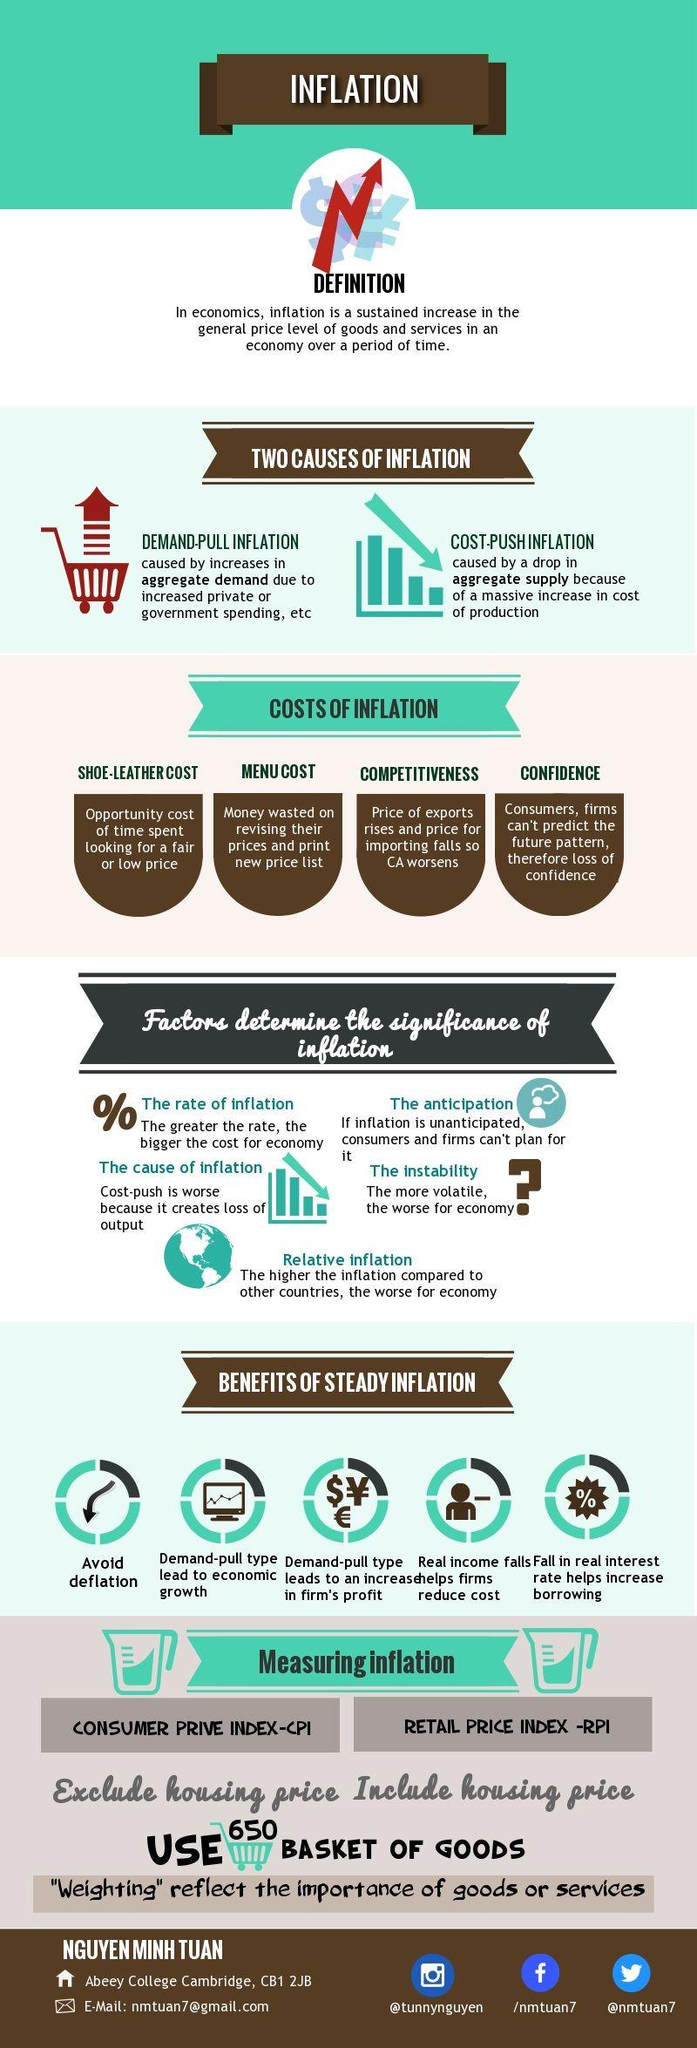Specify some key components in this picture. Four costs of inflation are involved. Steady inflation has several benefits, including increased consumer spending, lower real interest rates, and increased investment and productivity. Research has shown that steady inflation can lead to improved economic stability and growth. Although the optimal inflation rate is subject to debate, most economists agree that a moderate level of inflation is beneficial for a healthy economy. The Twitter handle of the student is @nmtuan7. 